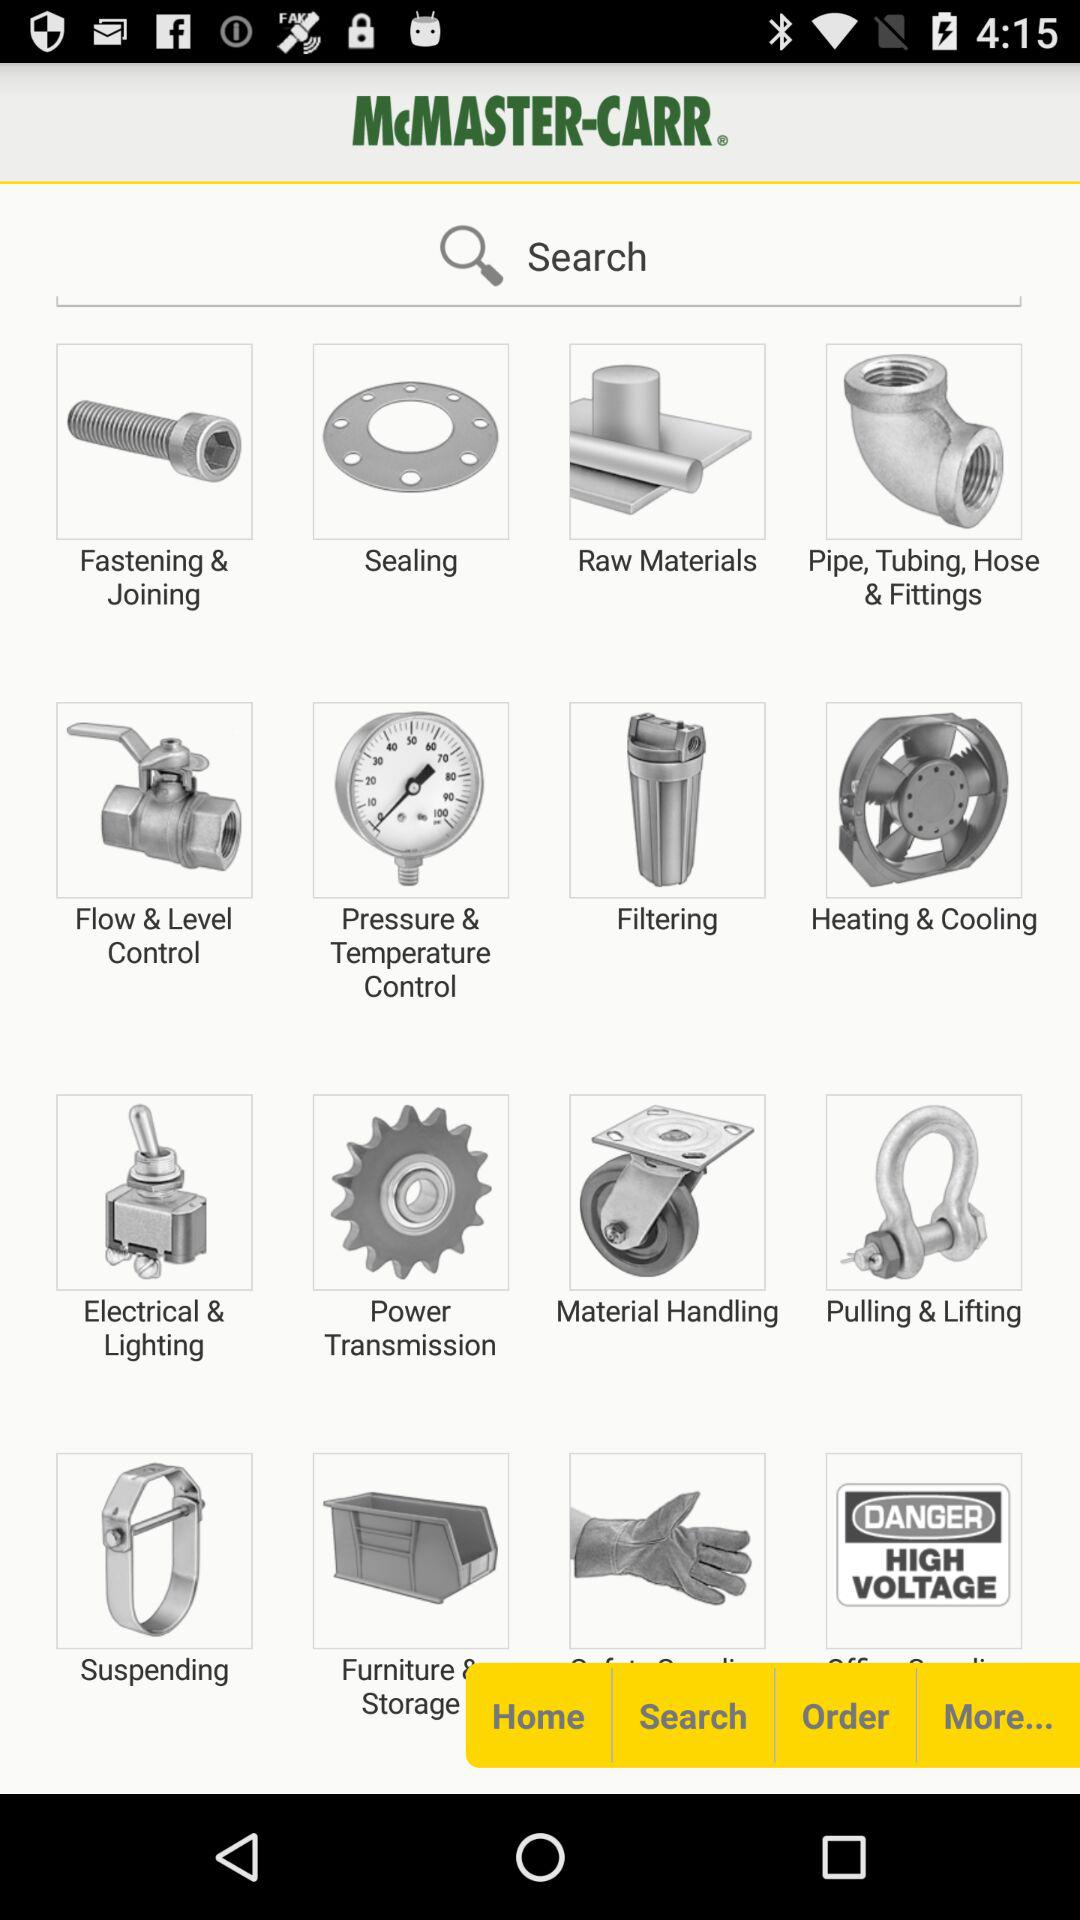What is the app name? The app name is "McMASTER-CARR". 